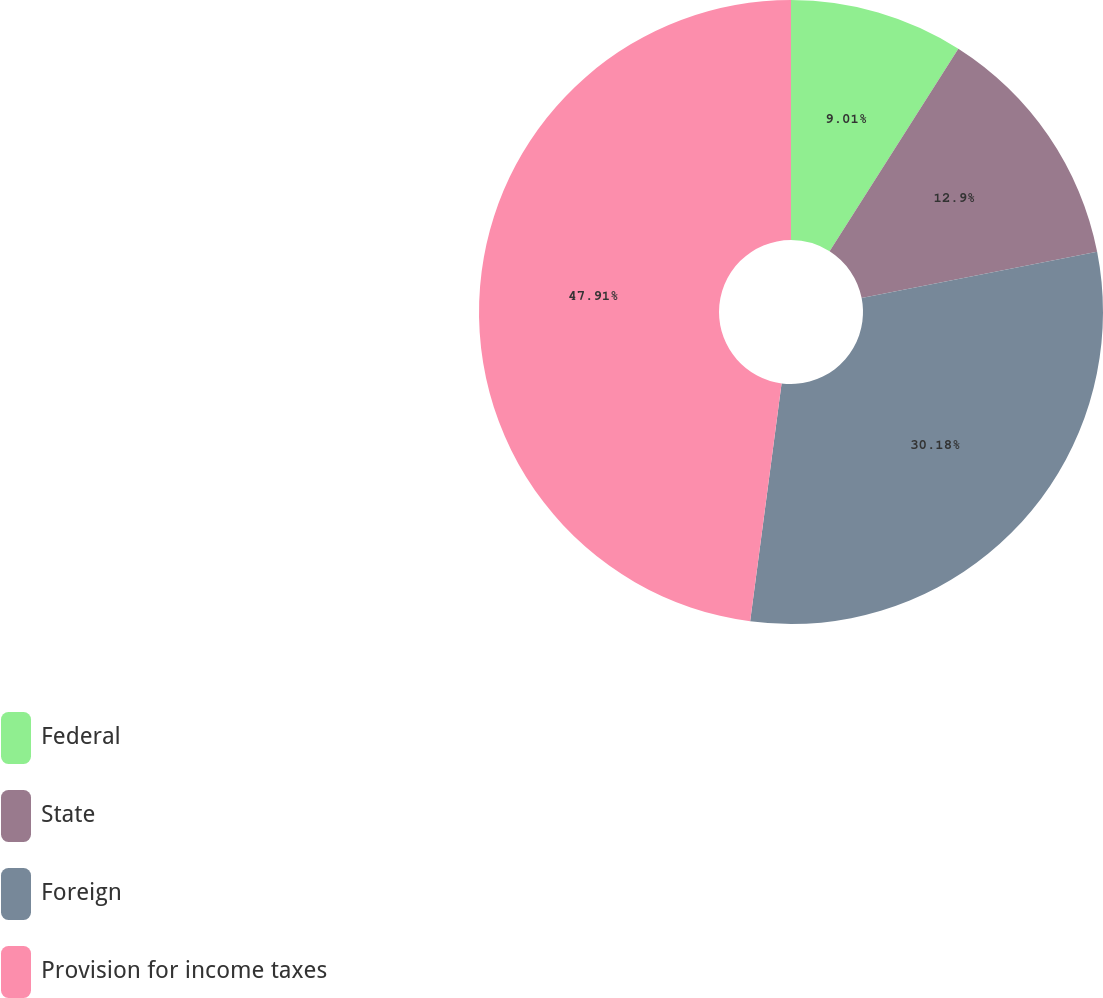Convert chart to OTSL. <chart><loc_0><loc_0><loc_500><loc_500><pie_chart><fcel>Federal<fcel>State<fcel>Foreign<fcel>Provision for income taxes<nl><fcel>9.01%<fcel>12.9%<fcel>30.18%<fcel>47.91%<nl></chart> 